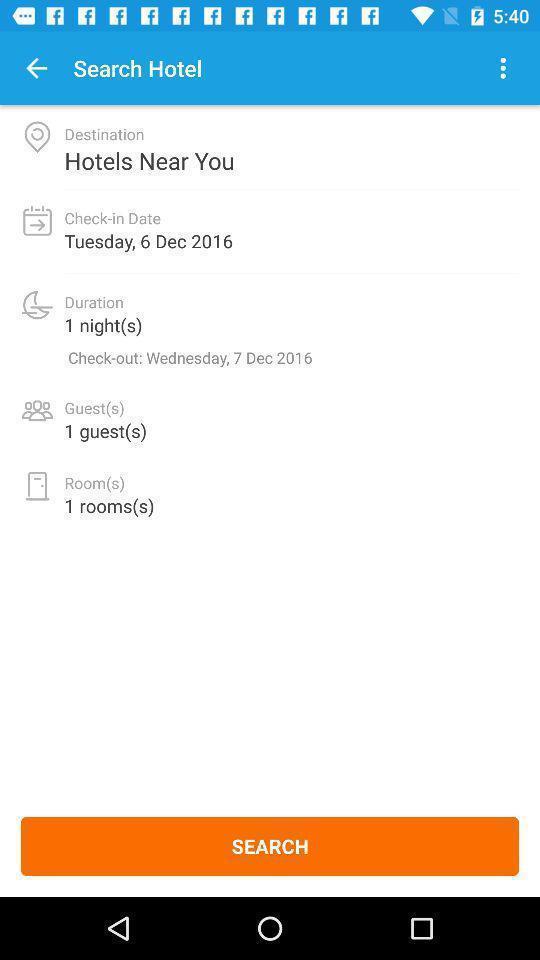What can you discern from this picture? Search page of a travel app. 